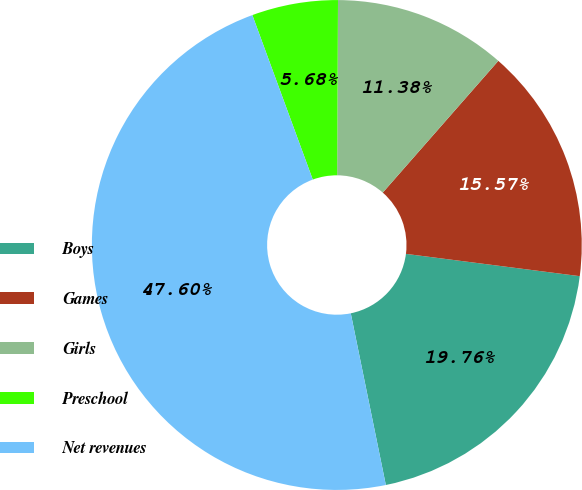Convert chart to OTSL. <chart><loc_0><loc_0><loc_500><loc_500><pie_chart><fcel>Boys<fcel>Games<fcel>Girls<fcel>Preschool<fcel>Net revenues<nl><fcel>19.76%<fcel>15.57%<fcel>11.38%<fcel>5.68%<fcel>47.6%<nl></chart> 